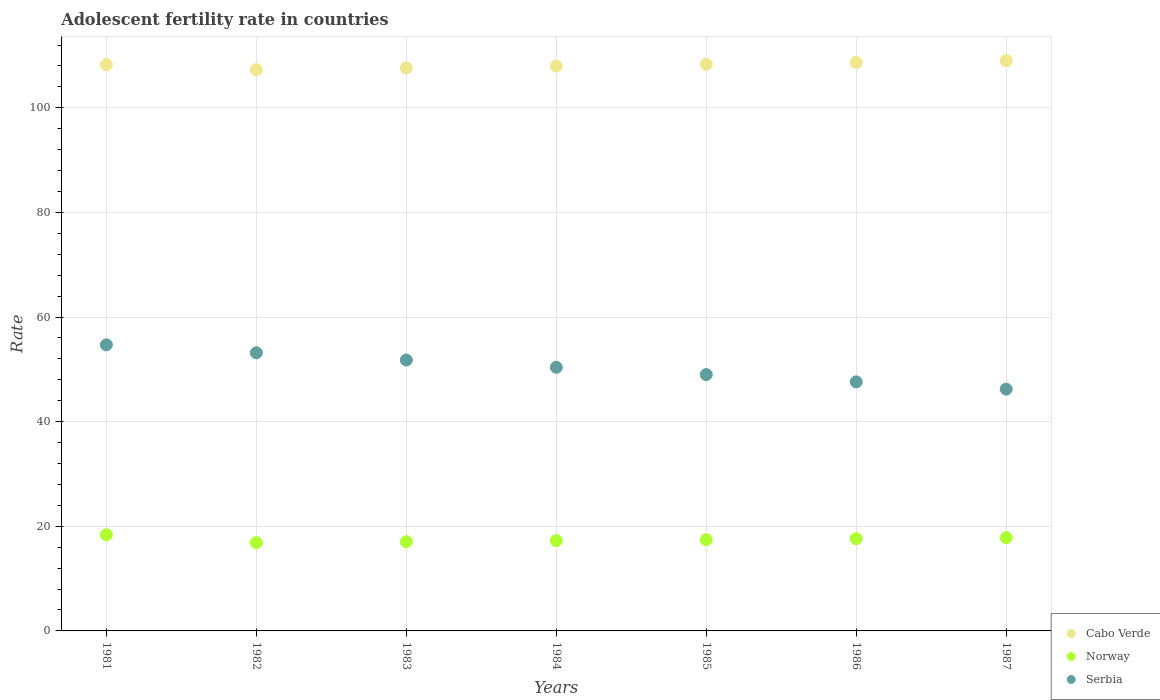Is the number of dotlines equal to the number of legend labels?
Your response must be concise. Yes. What is the adolescent fertility rate in Norway in 1981?
Make the answer very short. 18.38. Across all years, what is the maximum adolescent fertility rate in Norway?
Provide a succinct answer. 18.38. Across all years, what is the minimum adolescent fertility rate in Cabo Verde?
Make the answer very short. 107.29. In which year was the adolescent fertility rate in Norway maximum?
Keep it short and to the point. 1981. In which year was the adolescent fertility rate in Serbia minimum?
Give a very brief answer. 1987. What is the total adolescent fertility rate in Cabo Verde in the graph?
Offer a very short reply. 757.13. What is the difference between the adolescent fertility rate in Serbia in 1981 and that in 1987?
Offer a very short reply. 8.47. What is the difference between the adolescent fertility rate in Serbia in 1984 and the adolescent fertility rate in Norway in 1987?
Offer a very short reply. 32.57. What is the average adolescent fertility rate in Serbia per year?
Provide a succinct answer. 50.41. In the year 1983, what is the difference between the adolescent fertility rate in Serbia and adolescent fertility rate in Norway?
Keep it short and to the point. 34.72. What is the ratio of the adolescent fertility rate in Cabo Verde in 1985 to that in 1987?
Provide a short and direct response. 0.99. What is the difference between the highest and the second highest adolescent fertility rate in Serbia?
Provide a short and direct response. 1.52. What is the difference between the highest and the lowest adolescent fertility rate in Serbia?
Keep it short and to the point. 8.47. Is the sum of the adolescent fertility rate in Cabo Verde in 1984 and 1986 greater than the maximum adolescent fertility rate in Norway across all years?
Offer a terse response. Yes. Does the adolescent fertility rate in Serbia monotonically increase over the years?
Offer a terse response. No. Is the adolescent fertility rate in Norway strictly greater than the adolescent fertility rate in Cabo Verde over the years?
Keep it short and to the point. No. Is the adolescent fertility rate in Serbia strictly less than the adolescent fertility rate in Norway over the years?
Ensure brevity in your answer.  No. How many dotlines are there?
Your answer should be compact. 3. How many years are there in the graph?
Your answer should be very brief. 7. Does the graph contain grids?
Provide a succinct answer. Yes. Where does the legend appear in the graph?
Ensure brevity in your answer.  Bottom right. What is the title of the graph?
Ensure brevity in your answer.  Adolescent fertility rate in countries. Does "Solomon Islands" appear as one of the legend labels in the graph?
Your answer should be compact. No. What is the label or title of the Y-axis?
Ensure brevity in your answer.  Rate. What is the Rate of Cabo Verde in 1981?
Offer a terse response. 108.23. What is the Rate of Norway in 1981?
Your answer should be compact. 18.38. What is the Rate of Serbia in 1981?
Make the answer very short. 54.69. What is the Rate in Cabo Verde in 1982?
Keep it short and to the point. 107.29. What is the Rate of Norway in 1982?
Give a very brief answer. 16.88. What is the Rate of Serbia in 1982?
Your response must be concise. 53.17. What is the Rate in Cabo Verde in 1983?
Your answer should be very brief. 107.63. What is the Rate in Norway in 1983?
Provide a succinct answer. 17.07. What is the Rate in Serbia in 1983?
Ensure brevity in your answer.  51.78. What is the Rate in Cabo Verde in 1984?
Provide a succinct answer. 107.98. What is the Rate in Norway in 1984?
Make the answer very short. 17.26. What is the Rate of Serbia in 1984?
Your answer should be compact. 50.39. What is the Rate of Cabo Verde in 1985?
Your answer should be very brief. 108.32. What is the Rate in Norway in 1985?
Your response must be concise. 17.45. What is the Rate in Serbia in 1985?
Provide a short and direct response. 49. What is the Rate of Cabo Verde in 1986?
Make the answer very short. 108.67. What is the Rate of Norway in 1986?
Ensure brevity in your answer.  17.64. What is the Rate in Serbia in 1986?
Provide a short and direct response. 47.61. What is the Rate of Cabo Verde in 1987?
Offer a terse response. 109.01. What is the Rate of Norway in 1987?
Your response must be concise. 17.83. What is the Rate of Serbia in 1987?
Make the answer very short. 46.22. Across all years, what is the maximum Rate of Cabo Verde?
Give a very brief answer. 109.01. Across all years, what is the maximum Rate in Norway?
Offer a terse response. 18.38. Across all years, what is the maximum Rate in Serbia?
Keep it short and to the point. 54.69. Across all years, what is the minimum Rate of Cabo Verde?
Your answer should be compact. 107.29. Across all years, what is the minimum Rate of Norway?
Your answer should be very brief. 16.88. Across all years, what is the minimum Rate in Serbia?
Offer a very short reply. 46.22. What is the total Rate in Cabo Verde in the graph?
Offer a terse response. 757.13. What is the total Rate of Norway in the graph?
Your response must be concise. 122.49. What is the total Rate of Serbia in the graph?
Offer a very short reply. 352.89. What is the difference between the Rate of Cabo Verde in 1981 and that in 1982?
Make the answer very short. 0.94. What is the difference between the Rate of Norway in 1981 and that in 1982?
Your answer should be very brief. 1.5. What is the difference between the Rate in Serbia in 1981 and that in 1982?
Offer a terse response. 1.52. What is the difference between the Rate in Cabo Verde in 1981 and that in 1983?
Provide a short and direct response. 0.6. What is the difference between the Rate of Norway in 1981 and that in 1983?
Offer a very short reply. 1.31. What is the difference between the Rate in Serbia in 1981 and that in 1983?
Offer a very short reply. 2.91. What is the difference between the Rate of Cabo Verde in 1981 and that in 1984?
Your answer should be compact. 0.25. What is the difference between the Rate in Norway in 1981 and that in 1984?
Keep it short and to the point. 1.12. What is the difference between the Rate in Serbia in 1981 and that in 1984?
Keep it short and to the point. 4.3. What is the difference between the Rate in Cabo Verde in 1981 and that in 1985?
Provide a short and direct response. -0.09. What is the difference between the Rate in Norway in 1981 and that in 1985?
Give a very brief answer. 0.93. What is the difference between the Rate of Serbia in 1981 and that in 1985?
Provide a succinct answer. 5.69. What is the difference between the Rate in Cabo Verde in 1981 and that in 1986?
Offer a terse response. -0.44. What is the difference between the Rate in Norway in 1981 and that in 1986?
Provide a succinct answer. 0.74. What is the difference between the Rate of Serbia in 1981 and that in 1986?
Keep it short and to the point. 7.08. What is the difference between the Rate in Cabo Verde in 1981 and that in 1987?
Provide a succinct answer. -0.78. What is the difference between the Rate in Norway in 1981 and that in 1987?
Offer a very short reply. 0.55. What is the difference between the Rate of Serbia in 1981 and that in 1987?
Ensure brevity in your answer.  8.47. What is the difference between the Rate of Cabo Verde in 1982 and that in 1983?
Your answer should be compact. -0.34. What is the difference between the Rate in Norway in 1982 and that in 1983?
Your answer should be very brief. -0.19. What is the difference between the Rate of Serbia in 1982 and that in 1983?
Offer a very short reply. 1.39. What is the difference between the Rate in Cabo Verde in 1982 and that in 1984?
Give a very brief answer. -0.69. What is the difference between the Rate of Norway in 1982 and that in 1984?
Offer a very short reply. -0.38. What is the difference between the Rate of Serbia in 1982 and that in 1984?
Keep it short and to the point. 2.78. What is the difference between the Rate of Cabo Verde in 1982 and that in 1985?
Ensure brevity in your answer.  -1.03. What is the difference between the Rate of Norway in 1982 and that in 1985?
Your answer should be very brief. -0.57. What is the difference between the Rate of Serbia in 1982 and that in 1985?
Your response must be concise. 4.17. What is the difference between the Rate in Cabo Verde in 1982 and that in 1986?
Your response must be concise. -1.38. What is the difference between the Rate of Norway in 1982 and that in 1986?
Ensure brevity in your answer.  -0.76. What is the difference between the Rate in Serbia in 1982 and that in 1986?
Provide a short and direct response. 5.56. What is the difference between the Rate in Cabo Verde in 1982 and that in 1987?
Provide a succinct answer. -1.73. What is the difference between the Rate in Norway in 1982 and that in 1987?
Your answer should be compact. -0.95. What is the difference between the Rate in Serbia in 1982 and that in 1987?
Keep it short and to the point. 6.95. What is the difference between the Rate in Cabo Verde in 1983 and that in 1984?
Your response must be concise. -0.34. What is the difference between the Rate of Norway in 1983 and that in 1984?
Provide a succinct answer. -0.19. What is the difference between the Rate in Serbia in 1983 and that in 1984?
Make the answer very short. 1.39. What is the difference between the Rate in Cabo Verde in 1983 and that in 1985?
Keep it short and to the point. -0.69. What is the difference between the Rate in Norway in 1983 and that in 1985?
Your answer should be very brief. -0.38. What is the difference between the Rate in Serbia in 1983 and that in 1985?
Make the answer very short. 2.78. What is the difference between the Rate in Cabo Verde in 1983 and that in 1986?
Offer a terse response. -1.03. What is the difference between the Rate of Norway in 1983 and that in 1986?
Keep it short and to the point. -0.57. What is the difference between the Rate in Serbia in 1983 and that in 1986?
Make the answer very short. 4.17. What is the difference between the Rate of Cabo Verde in 1983 and that in 1987?
Provide a short and direct response. -1.38. What is the difference between the Rate of Norway in 1983 and that in 1987?
Provide a short and direct response. -0.76. What is the difference between the Rate of Serbia in 1983 and that in 1987?
Your answer should be very brief. 5.56. What is the difference between the Rate of Cabo Verde in 1984 and that in 1985?
Ensure brevity in your answer.  -0.34. What is the difference between the Rate in Norway in 1984 and that in 1985?
Your response must be concise. -0.19. What is the difference between the Rate of Serbia in 1984 and that in 1985?
Make the answer very short. 1.39. What is the difference between the Rate in Cabo Verde in 1984 and that in 1986?
Ensure brevity in your answer.  -0.69. What is the difference between the Rate in Norway in 1984 and that in 1986?
Give a very brief answer. -0.38. What is the difference between the Rate in Serbia in 1984 and that in 1986?
Your answer should be compact. 2.78. What is the difference between the Rate in Cabo Verde in 1984 and that in 1987?
Your answer should be compact. -1.03. What is the difference between the Rate of Norway in 1984 and that in 1987?
Your answer should be compact. -0.57. What is the difference between the Rate of Serbia in 1984 and that in 1987?
Your answer should be very brief. 4.17. What is the difference between the Rate in Cabo Verde in 1985 and that in 1986?
Make the answer very short. -0.34. What is the difference between the Rate of Norway in 1985 and that in 1986?
Provide a short and direct response. -0.19. What is the difference between the Rate in Serbia in 1985 and that in 1986?
Your answer should be compact. 1.39. What is the difference between the Rate in Cabo Verde in 1985 and that in 1987?
Offer a very short reply. -0.69. What is the difference between the Rate in Norway in 1985 and that in 1987?
Ensure brevity in your answer.  -0.38. What is the difference between the Rate of Serbia in 1985 and that in 1987?
Keep it short and to the point. 2.78. What is the difference between the Rate in Cabo Verde in 1986 and that in 1987?
Provide a succinct answer. -0.34. What is the difference between the Rate in Norway in 1986 and that in 1987?
Provide a short and direct response. -0.19. What is the difference between the Rate of Serbia in 1986 and that in 1987?
Provide a short and direct response. 1.39. What is the difference between the Rate in Cabo Verde in 1981 and the Rate in Norway in 1982?
Provide a short and direct response. 91.35. What is the difference between the Rate in Cabo Verde in 1981 and the Rate in Serbia in 1982?
Give a very brief answer. 55.05. What is the difference between the Rate in Norway in 1981 and the Rate in Serbia in 1982?
Ensure brevity in your answer.  -34.8. What is the difference between the Rate of Cabo Verde in 1981 and the Rate of Norway in 1983?
Make the answer very short. 91.16. What is the difference between the Rate in Cabo Verde in 1981 and the Rate in Serbia in 1983?
Offer a very short reply. 56.44. What is the difference between the Rate of Norway in 1981 and the Rate of Serbia in 1983?
Make the answer very short. -33.41. What is the difference between the Rate of Cabo Verde in 1981 and the Rate of Norway in 1984?
Keep it short and to the point. 90.97. What is the difference between the Rate of Cabo Verde in 1981 and the Rate of Serbia in 1984?
Give a very brief answer. 57.83. What is the difference between the Rate of Norway in 1981 and the Rate of Serbia in 1984?
Offer a terse response. -32.02. What is the difference between the Rate in Cabo Verde in 1981 and the Rate in Norway in 1985?
Give a very brief answer. 90.78. What is the difference between the Rate in Cabo Verde in 1981 and the Rate in Serbia in 1985?
Ensure brevity in your answer.  59.23. What is the difference between the Rate of Norway in 1981 and the Rate of Serbia in 1985?
Provide a short and direct response. -30.63. What is the difference between the Rate of Cabo Verde in 1981 and the Rate of Norway in 1986?
Your response must be concise. 90.59. What is the difference between the Rate in Cabo Verde in 1981 and the Rate in Serbia in 1986?
Give a very brief answer. 60.62. What is the difference between the Rate of Norway in 1981 and the Rate of Serbia in 1986?
Provide a short and direct response. -29.24. What is the difference between the Rate in Cabo Verde in 1981 and the Rate in Norway in 1987?
Your response must be concise. 90.4. What is the difference between the Rate of Cabo Verde in 1981 and the Rate of Serbia in 1987?
Ensure brevity in your answer.  62.01. What is the difference between the Rate of Norway in 1981 and the Rate of Serbia in 1987?
Your answer should be compact. -27.85. What is the difference between the Rate in Cabo Verde in 1982 and the Rate in Norway in 1983?
Offer a terse response. 90.22. What is the difference between the Rate of Cabo Verde in 1982 and the Rate of Serbia in 1983?
Your response must be concise. 55.5. What is the difference between the Rate of Norway in 1982 and the Rate of Serbia in 1983?
Make the answer very short. -34.91. What is the difference between the Rate of Cabo Verde in 1982 and the Rate of Norway in 1984?
Give a very brief answer. 90.03. What is the difference between the Rate of Cabo Verde in 1982 and the Rate of Serbia in 1984?
Provide a succinct answer. 56.89. What is the difference between the Rate of Norway in 1982 and the Rate of Serbia in 1984?
Your answer should be very brief. -33.52. What is the difference between the Rate of Cabo Verde in 1982 and the Rate of Norway in 1985?
Provide a succinct answer. 89.84. What is the difference between the Rate in Cabo Verde in 1982 and the Rate in Serbia in 1985?
Your answer should be compact. 58.28. What is the difference between the Rate of Norway in 1982 and the Rate of Serbia in 1985?
Provide a short and direct response. -32.13. What is the difference between the Rate in Cabo Verde in 1982 and the Rate in Norway in 1986?
Offer a very short reply. 89.65. What is the difference between the Rate in Cabo Verde in 1982 and the Rate in Serbia in 1986?
Offer a terse response. 59.67. What is the difference between the Rate of Norway in 1982 and the Rate of Serbia in 1986?
Offer a very short reply. -30.74. What is the difference between the Rate in Cabo Verde in 1982 and the Rate in Norway in 1987?
Give a very brief answer. 89.46. What is the difference between the Rate in Cabo Verde in 1982 and the Rate in Serbia in 1987?
Ensure brevity in your answer.  61.06. What is the difference between the Rate of Norway in 1982 and the Rate of Serbia in 1987?
Ensure brevity in your answer.  -29.35. What is the difference between the Rate in Cabo Verde in 1983 and the Rate in Norway in 1984?
Ensure brevity in your answer.  90.38. What is the difference between the Rate of Cabo Verde in 1983 and the Rate of Serbia in 1984?
Ensure brevity in your answer.  57.24. What is the difference between the Rate in Norway in 1983 and the Rate in Serbia in 1984?
Offer a terse response. -33.33. What is the difference between the Rate in Cabo Verde in 1983 and the Rate in Norway in 1985?
Provide a short and direct response. 90.19. What is the difference between the Rate in Cabo Verde in 1983 and the Rate in Serbia in 1985?
Ensure brevity in your answer.  58.63. What is the difference between the Rate in Norway in 1983 and the Rate in Serbia in 1985?
Your response must be concise. -31.94. What is the difference between the Rate of Cabo Verde in 1983 and the Rate of Norway in 1986?
Your answer should be very brief. 90. What is the difference between the Rate of Cabo Verde in 1983 and the Rate of Serbia in 1986?
Your answer should be very brief. 60.02. What is the difference between the Rate of Norway in 1983 and the Rate of Serbia in 1986?
Your answer should be very brief. -30.55. What is the difference between the Rate in Cabo Verde in 1983 and the Rate in Norway in 1987?
Your answer should be compact. 89.81. What is the difference between the Rate of Cabo Verde in 1983 and the Rate of Serbia in 1987?
Ensure brevity in your answer.  61.41. What is the difference between the Rate in Norway in 1983 and the Rate in Serbia in 1987?
Offer a terse response. -29.16. What is the difference between the Rate in Cabo Verde in 1984 and the Rate in Norway in 1985?
Your response must be concise. 90.53. What is the difference between the Rate in Cabo Verde in 1984 and the Rate in Serbia in 1985?
Provide a short and direct response. 58.97. What is the difference between the Rate in Norway in 1984 and the Rate in Serbia in 1985?
Your answer should be very brief. -31.75. What is the difference between the Rate in Cabo Verde in 1984 and the Rate in Norway in 1986?
Offer a terse response. 90.34. What is the difference between the Rate in Cabo Verde in 1984 and the Rate in Serbia in 1986?
Your answer should be very brief. 60.36. What is the difference between the Rate in Norway in 1984 and the Rate in Serbia in 1986?
Provide a succinct answer. -30.36. What is the difference between the Rate of Cabo Verde in 1984 and the Rate of Norway in 1987?
Offer a terse response. 90.15. What is the difference between the Rate in Cabo Verde in 1984 and the Rate in Serbia in 1987?
Give a very brief answer. 61.76. What is the difference between the Rate of Norway in 1984 and the Rate of Serbia in 1987?
Ensure brevity in your answer.  -28.97. What is the difference between the Rate in Cabo Verde in 1985 and the Rate in Norway in 1986?
Ensure brevity in your answer.  90.69. What is the difference between the Rate of Cabo Verde in 1985 and the Rate of Serbia in 1986?
Provide a short and direct response. 60.71. What is the difference between the Rate of Norway in 1985 and the Rate of Serbia in 1986?
Offer a terse response. -30.17. What is the difference between the Rate of Cabo Verde in 1985 and the Rate of Norway in 1987?
Your answer should be compact. 90.5. What is the difference between the Rate of Cabo Verde in 1985 and the Rate of Serbia in 1987?
Provide a succinct answer. 62.1. What is the difference between the Rate in Norway in 1985 and the Rate in Serbia in 1987?
Your response must be concise. -28.78. What is the difference between the Rate in Cabo Verde in 1986 and the Rate in Norway in 1987?
Your response must be concise. 90.84. What is the difference between the Rate in Cabo Verde in 1986 and the Rate in Serbia in 1987?
Keep it short and to the point. 62.45. What is the difference between the Rate of Norway in 1986 and the Rate of Serbia in 1987?
Make the answer very short. -28.59. What is the average Rate in Cabo Verde per year?
Provide a succinct answer. 108.16. What is the average Rate in Norway per year?
Ensure brevity in your answer.  17.5. What is the average Rate of Serbia per year?
Ensure brevity in your answer.  50.41. In the year 1981, what is the difference between the Rate in Cabo Verde and Rate in Norway?
Ensure brevity in your answer.  89.85. In the year 1981, what is the difference between the Rate of Cabo Verde and Rate of Serbia?
Ensure brevity in your answer.  53.54. In the year 1981, what is the difference between the Rate of Norway and Rate of Serbia?
Provide a succinct answer. -36.31. In the year 1982, what is the difference between the Rate in Cabo Verde and Rate in Norway?
Offer a very short reply. 90.41. In the year 1982, what is the difference between the Rate of Cabo Verde and Rate of Serbia?
Your answer should be very brief. 54.11. In the year 1982, what is the difference between the Rate of Norway and Rate of Serbia?
Your answer should be compact. -36.3. In the year 1983, what is the difference between the Rate in Cabo Verde and Rate in Norway?
Offer a terse response. 90.57. In the year 1983, what is the difference between the Rate in Cabo Verde and Rate in Serbia?
Provide a short and direct response. 55.85. In the year 1983, what is the difference between the Rate of Norway and Rate of Serbia?
Your answer should be compact. -34.72. In the year 1984, what is the difference between the Rate of Cabo Verde and Rate of Norway?
Keep it short and to the point. 90.72. In the year 1984, what is the difference between the Rate of Cabo Verde and Rate of Serbia?
Offer a terse response. 57.58. In the year 1984, what is the difference between the Rate in Norway and Rate in Serbia?
Keep it short and to the point. -33.14. In the year 1985, what is the difference between the Rate in Cabo Verde and Rate in Norway?
Your answer should be compact. 90.88. In the year 1985, what is the difference between the Rate in Cabo Verde and Rate in Serbia?
Keep it short and to the point. 59.32. In the year 1985, what is the difference between the Rate in Norway and Rate in Serbia?
Ensure brevity in your answer.  -31.56. In the year 1986, what is the difference between the Rate of Cabo Verde and Rate of Norway?
Ensure brevity in your answer.  91.03. In the year 1986, what is the difference between the Rate of Cabo Verde and Rate of Serbia?
Your answer should be compact. 61.05. In the year 1986, what is the difference between the Rate of Norway and Rate of Serbia?
Your answer should be very brief. -29.98. In the year 1987, what is the difference between the Rate of Cabo Verde and Rate of Norway?
Offer a terse response. 91.19. In the year 1987, what is the difference between the Rate in Cabo Verde and Rate in Serbia?
Ensure brevity in your answer.  62.79. In the year 1987, what is the difference between the Rate of Norway and Rate of Serbia?
Make the answer very short. -28.4. What is the ratio of the Rate of Cabo Verde in 1981 to that in 1982?
Your answer should be compact. 1.01. What is the ratio of the Rate of Norway in 1981 to that in 1982?
Make the answer very short. 1.09. What is the ratio of the Rate of Serbia in 1981 to that in 1982?
Provide a short and direct response. 1.03. What is the ratio of the Rate in Norway in 1981 to that in 1983?
Make the answer very short. 1.08. What is the ratio of the Rate of Serbia in 1981 to that in 1983?
Give a very brief answer. 1.06. What is the ratio of the Rate in Cabo Verde in 1981 to that in 1984?
Offer a terse response. 1. What is the ratio of the Rate of Norway in 1981 to that in 1984?
Offer a very short reply. 1.06. What is the ratio of the Rate of Serbia in 1981 to that in 1984?
Keep it short and to the point. 1.09. What is the ratio of the Rate in Cabo Verde in 1981 to that in 1985?
Keep it short and to the point. 1. What is the ratio of the Rate in Norway in 1981 to that in 1985?
Ensure brevity in your answer.  1.05. What is the ratio of the Rate of Serbia in 1981 to that in 1985?
Your answer should be very brief. 1.12. What is the ratio of the Rate of Cabo Verde in 1981 to that in 1986?
Keep it short and to the point. 1. What is the ratio of the Rate of Norway in 1981 to that in 1986?
Offer a very short reply. 1.04. What is the ratio of the Rate in Serbia in 1981 to that in 1986?
Offer a very short reply. 1.15. What is the ratio of the Rate of Cabo Verde in 1981 to that in 1987?
Make the answer very short. 0.99. What is the ratio of the Rate of Norway in 1981 to that in 1987?
Your answer should be compact. 1.03. What is the ratio of the Rate of Serbia in 1981 to that in 1987?
Your answer should be very brief. 1.18. What is the ratio of the Rate of Norway in 1982 to that in 1983?
Ensure brevity in your answer.  0.99. What is the ratio of the Rate of Serbia in 1982 to that in 1983?
Provide a succinct answer. 1.03. What is the ratio of the Rate of Cabo Verde in 1982 to that in 1984?
Provide a succinct answer. 0.99. What is the ratio of the Rate in Norway in 1982 to that in 1984?
Offer a terse response. 0.98. What is the ratio of the Rate of Serbia in 1982 to that in 1984?
Ensure brevity in your answer.  1.06. What is the ratio of the Rate in Norway in 1982 to that in 1985?
Provide a succinct answer. 0.97. What is the ratio of the Rate in Serbia in 1982 to that in 1985?
Provide a short and direct response. 1.09. What is the ratio of the Rate in Cabo Verde in 1982 to that in 1986?
Provide a succinct answer. 0.99. What is the ratio of the Rate in Norway in 1982 to that in 1986?
Your answer should be very brief. 0.96. What is the ratio of the Rate in Serbia in 1982 to that in 1986?
Make the answer very short. 1.12. What is the ratio of the Rate in Cabo Verde in 1982 to that in 1987?
Make the answer very short. 0.98. What is the ratio of the Rate of Norway in 1982 to that in 1987?
Ensure brevity in your answer.  0.95. What is the ratio of the Rate in Serbia in 1982 to that in 1987?
Ensure brevity in your answer.  1.15. What is the ratio of the Rate in Serbia in 1983 to that in 1984?
Offer a very short reply. 1.03. What is the ratio of the Rate of Cabo Verde in 1983 to that in 1985?
Give a very brief answer. 0.99. What is the ratio of the Rate of Norway in 1983 to that in 1985?
Your answer should be very brief. 0.98. What is the ratio of the Rate in Serbia in 1983 to that in 1985?
Provide a succinct answer. 1.06. What is the ratio of the Rate in Cabo Verde in 1983 to that in 1986?
Make the answer very short. 0.99. What is the ratio of the Rate in Norway in 1983 to that in 1986?
Keep it short and to the point. 0.97. What is the ratio of the Rate of Serbia in 1983 to that in 1986?
Keep it short and to the point. 1.09. What is the ratio of the Rate in Cabo Verde in 1983 to that in 1987?
Your response must be concise. 0.99. What is the ratio of the Rate of Norway in 1983 to that in 1987?
Offer a terse response. 0.96. What is the ratio of the Rate of Serbia in 1983 to that in 1987?
Make the answer very short. 1.12. What is the ratio of the Rate in Cabo Verde in 1984 to that in 1985?
Ensure brevity in your answer.  1. What is the ratio of the Rate of Norway in 1984 to that in 1985?
Your answer should be compact. 0.99. What is the ratio of the Rate in Serbia in 1984 to that in 1985?
Your response must be concise. 1.03. What is the ratio of the Rate of Cabo Verde in 1984 to that in 1986?
Your answer should be very brief. 0.99. What is the ratio of the Rate in Norway in 1984 to that in 1986?
Keep it short and to the point. 0.98. What is the ratio of the Rate in Serbia in 1984 to that in 1986?
Ensure brevity in your answer.  1.06. What is the ratio of the Rate in Cabo Verde in 1984 to that in 1987?
Make the answer very short. 0.99. What is the ratio of the Rate in Norway in 1984 to that in 1987?
Your response must be concise. 0.97. What is the ratio of the Rate of Serbia in 1984 to that in 1987?
Ensure brevity in your answer.  1.09. What is the ratio of the Rate in Serbia in 1985 to that in 1986?
Provide a succinct answer. 1.03. What is the ratio of the Rate in Cabo Verde in 1985 to that in 1987?
Your answer should be very brief. 0.99. What is the ratio of the Rate of Norway in 1985 to that in 1987?
Your answer should be compact. 0.98. What is the ratio of the Rate in Serbia in 1985 to that in 1987?
Provide a succinct answer. 1.06. What is the ratio of the Rate in Norway in 1986 to that in 1987?
Provide a short and direct response. 0.99. What is the ratio of the Rate of Serbia in 1986 to that in 1987?
Make the answer very short. 1.03. What is the difference between the highest and the second highest Rate of Cabo Verde?
Make the answer very short. 0.34. What is the difference between the highest and the second highest Rate of Norway?
Offer a terse response. 0.55. What is the difference between the highest and the second highest Rate of Serbia?
Your answer should be very brief. 1.52. What is the difference between the highest and the lowest Rate in Cabo Verde?
Ensure brevity in your answer.  1.73. What is the difference between the highest and the lowest Rate of Norway?
Offer a very short reply. 1.5. What is the difference between the highest and the lowest Rate in Serbia?
Offer a very short reply. 8.47. 